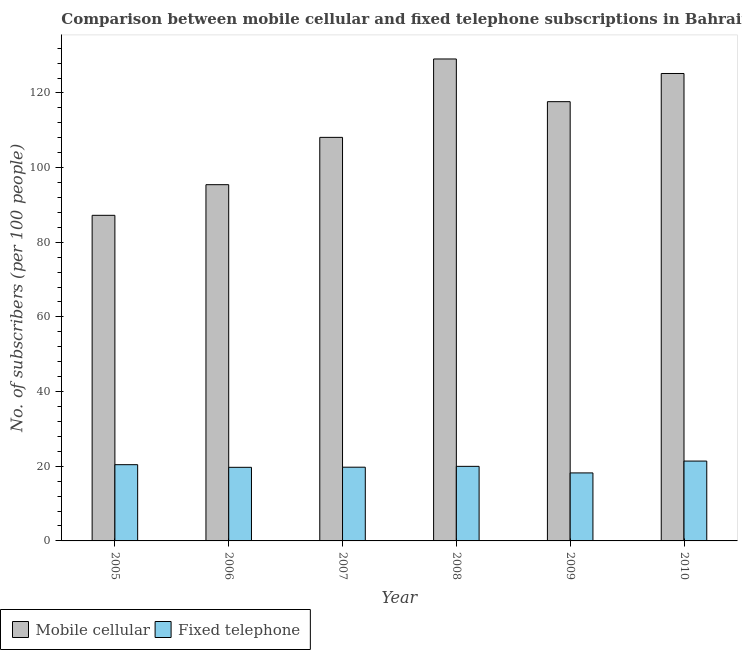Are the number of bars on each tick of the X-axis equal?
Provide a short and direct response. Yes. How many bars are there on the 6th tick from the left?
Offer a terse response. 2. In how many cases, is the number of bars for a given year not equal to the number of legend labels?
Make the answer very short. 0. What is the number of fixed telephone subscribers in 2007?
Provide a succinct answer. 19.75. Across all years, what is the maximum number of fixed telephone subscribers?
Your answer should be very brief. 21.39. Across all years, what is the minimum number of fixed telephone subscribers?
Make the answer very short. 18.22. In which year was the number of mobile cellular subscribers minimum?
Ensure brevity in your answer.  2005. What is the total number of fixed telephone subscribers in the graph?
Offer a very short reply. 119.47. What is the difference between the number of mobile cellular subscribers in 2005 and that in 2010?
Offer a very short reply. -37.99. What is the difference between the number of fixed telephone subscribers in 2007 and the number of mobile cellular subscribers in 2009?
Your response must be concise. 1.53. What is the average number of fixed telephone subscribers per year?
Make the answer very short. 19.91. In the year 2006, what is the difference between the number of fixed telephone subscribers and number of mobile cellular subscribers?
Your answer should be very brief. 0. What is the ratio of the number of mobile cellular subscribers in 2009 to that in 2010?
Give a very brief answer. 0.94. Is the number of mobile cellular subscribers in 2009 less than that in 2010?
Ensure brevity in your answer.  Yes. Is the difference between the number of fixed telephone subscribers in 2007 and 2010 greater than the difference between the number of mobile cellular subscribers in 2007 and 2010?
Provide a short and direct response. No. What is the difference between the highest and the second highest number of mobile cellular subscribers?
Your answer should be compact. 3.89. What is the difference between the highest and the lowest number of mobile cellular subscribers?
Ensure brevity in your answer.  41.88. In how many years, is the number of fixed telephone subscribers greater than the average number of fixed telephone subscribers taken over all years?
Your answer should be very brief. 3. What does the 2nd bar from the left in 2010 represents?
Your answer should be very brief. Fixed telephone. What does the 2nd bar from the right in 2009 represents?
Give a very brief answer. Mobile cellular. How many bars are there?
Offer a very short reply. 12. Are all the bars in the graph horizontal?
Your answer should be very brief. No. How many years are there in the graph?
Offer a very short reply. 6. What is the difference between two consecutive major ticks on the Y-axis?
Offer a terse response. 20. Are the values on the major ticks of Y-axis written in scientific E-notation?
Your answer should be compact. No. Does the graph contain grids?
Your answer should be compact. No. Where does the legend appear in the graph?
Your answer should be compact. Bottom left. How many legend labels are there?
Provide a short and direct response. 2. What is the title of the graph?
Offer a very short reply. Comparison between mobile cellular and fixed telephone subscriptions in Bahrain. Does "Resident" appear as one of the legend labels in the graph?
Your answer should be compact. No. What is the label or title of the X-axis?
Your answer should be very brief. Year. What is the label or title of the Y-axis?
Ensure brevity in your answer.  No. of subscribers (per 100 people). What is the No. of subscribers (per 100 people) of Mobile cellular in 2005?
Your response must be concise. 87.22. What is the No. of subscribers (per 100 people) in Fixed telephone in 2005?
Make the answer very short. 20.42. What is the No. of subscribers (per 100 people) of Mobile cellular in 2006?
Your response must be concise. 95.42. What is the No. of subscribers (per 100 people) of Fixed telephone in 2006?
Ensure brevity in your answer.  19.72. What is the No. of subscribers (per 100 people) of Mobile cellular in 2007?
Provide a succinct answer. 108.1. What is the No. of subscribers (per 100 people) of Fixed telephone in 2007?
Your answer should be very brief. 19.75. What is the No. of subscribers (per 100 people) of Mobile cellular in 2008?
Make the answer very short. 129.1. What is the No. of subscribers (per 100 people) in Fixed telephone in 2008?
Provide a short and direct response. 19.97. What is the No. of subscribers (per 100 people) of Mobile cellular in 2009?
Keep it short and to the point. 117.66. What is the No. of subscribers (per 100 people) of Fixed telephone in 2009?
Your answer should be compact. 18.22. What is the No. of subscribers (per 100 people) of Mobile cellular in 2010?
Keep it short and to the point. 125.21. What is the No. of subscribers (per 100 people) of Fixed telephone in 2010?
Keep it short and to the point. 21.39. Across all years, what is the maximum No. of subscribers (per 100 people) of Mobile cellular?
Give a very brief answer. 129.1. Across all years, what is the maximum No. of subscribers (per 100 people) in Fixed telephone?
Offer a very short reply. 21.39. Across all years, what is the minimum No. of subscribers (per 100 people) of Mobile cellular?
Give a very brief answer. 87.22. Across all years, what is the minimum No. of subscribers (per 100 people) in Fixed telephone?
Offer a terse response. 18.22. What is the total No. of subscribers (per 100 people) of Mobile cellular in the graph?
Your response must be concise. 662.71. What is the total No. of subscribers (per 100 people) of Fixed telephone in the graph?
Give a very brief answer. 119.47. What is the difference between the No. of subscribers (per 100 people) in Mobile cellular in 2005 and that in 2006?
Your answer should be compact. -8.21. What is the difference between the No. of subscribers (per 100 people) of Fixed telephone in 2005 and that in 2006?
Provide a succinct answer. 0.7. What is the difference between the No. of subscribers (per 100 people) in Mobile cellular in 2005 and that in 2007?
Provide a succinct answer. -20.88. What is the difference between the No. of subscribers (per 100 people) in Fixed telephone in 2005 and that in 2007?
Make the answer very short. 0.67. What is the difference between the No. of subscribers (per 100 people) in Mobile cellular in 2005 and that in 2008?
Your answer should be compact. -41.88. What is the difference between the No. of subscribers (per 100 people) in Fixed telephone in 2005 and that in 2008?
Your answer should be compact. 0.45. What is the difference between the No. of subscribers (per 100 people) of Mobile cellular in 2005 and that in 2009?
Offer a very short reply. -30.44. What is the difference between the No. of subscribers (per 100 people) of Fixed telephone in 2005 and that in 2009?
Your response must be concise. 2.2. What is the difference between the No. of subscribers (per 100 people) in Mobile cellular in 2005 and that in 2010?
Offer a very short reply. -37.99. What is the difference between the No. of subscribers (per 100 people) in Fixed telephone in 2005 and that in 2010?
Your answer should be compact. -0.97. What is the difference between the No. of subscribers (per 100 people) of Mobile cellular in 2006 and that in 2007?
Your answer should be compact. -12.68. What is the difference between the No. of subscribers (per 100 people) in Fixed telephone in 2006 and that in 2007?
Keep it short and to the point. -0.03. What is the difference between the No. of subscribers (per 100 people) of Mobile cellular in 2006 and that in 2008?
Ensure brevity in your answer.  -33.67. What is the difference between the No. of subscribers (per 100 people) in Fixed telephone in 2006 and that in 2008?
Your answer should be compact. -0.26. What is the difference between the No. of subscribers (per 100 people) in Mobile cellular in 2006 and that in 2009?
Make the answer very short. -22.24. What is the difference between the No. of subscribers (per 100 people) of Fixed telephone in 2006 and that in 2009?
Give a very brief answer. 1.5. What is the difference between the No. of subscribers (per 100 people) of Mobile cellular in 2006 and that in 2010?
Provide a succinct answer. -29.78. What is the difference between the No. of subscribers (per 100 people) of Fixed telephone in 2006 and that in 2010?
Your answer should be very brief. -1.67. What is the difference between the No. of subscribers (per 100 people) of Mobile cellular in 2007 and that in 2008?
Your response must be concise. -21. What is the difference between the No. of subscribers (per 100 people) in Fixed telephone in 2007 and that in 2008?
Your answer should be very brief. -0.23. What is the difference between the No. of subscribers (per 100 people) of Mobile cellular in 2007 and that in 2009?
Provide a short and direct response. -9.56. What is the difference between the No. of subscribers (per 100 people) in Fixed telephone in 2007 and that in 2009?
Offer a terse response. 1.53. What is the difference between the No. of subscribers (per 100 people) in Mobile cellular in 2007 and that in 2010?
Offer a terse response. -17.11. What is the difference between the No. of subscribers (per 100 people) of Fixed telephone in 2007 and that in 2010?
Ensure brevity in your answer.  -1.64. What is the difference between the No. of subscribers (per 100 people) in Mobile cellular in 2008 and that in 2009?
Make the answer very short. 11.44. What is the difference between the No. of subscribers (per 100 people) in Fixed telephone in 2008 and that in 2009?
Your answer should be very brief. 1.76. What is the difference between the No. of subscribers (per 100 people) of Mobile cellular in 2008 and that in 2010?
Ensure brevity in your answer.  3.89. What is the difference between the No. of subscribers (per 100 people) of Fixed telephone in 2008 and that in 2010?
Offer a terse response. -1.42. What is the difference between the No. of subscribers (per 100 people) of Mobile cellular in 2009 and that in 2010?
Ensure brevity in your answer.  -7.55. What is the difference between the No. of subscribers (per 100 people) of Fixed telephone in 2009 and that in 2010?
Keep it short and to the point. -3.17. What is the difference between the No. of subscribers (per 100 people) in Mobile cellular in 2005 and the No. of subscribers (per 100 people) in Fixed telephone in 2006?
Your answer should be very brief. 67.5. What is the difference between the No. of subscribers (per 100 people) in Mobile cellular in 2005 and the No. of subscribers (per 100 people) in Fixed telephone in 2007?
Offer a terse response. 67.47. What is the difference between the No. of subscribers (per 100 people) of Mobile cellular in 2005 and the No. of subscribers (per 100 people) of Fixed telephone in 2008?
Keep it short and to the point. 67.24. What is the difference between the No. of subscribers (per 100 people) of Mobile cellular in 2005 and the No. of subscribers (per 100 people) of Fixed telephone in 2009?
Your response must be concise. 69. What is the difference between the No. of subscribers (per 100 people) in Mobile cellular in 2005 and the No. of subscribers (per 100 people) in Fixed telephone in 2010?
Provide a succinct answer. 65.83. What is the difference between the No. of subscribers (per 100 people) of Mobile cellular in 2006 and the No. of subscribers (per 100 people) of Fixed telephone in 2007?
Give a very brief answer. 75.68. What is the difference between the No. of subscribers (per 100 people) of Mobile cellular in 2006 and the No. of subscribers (per 100 people) of Fixed telephone in 2008?
Your response must be concise. 75.45. What is the difference between the No. of subscribers (per 100 people) of Mobile cellular in 2006 and the No. of subscribers (per 100 people) of Fixed telephone in 2009?
Ensure brevity in your answer.  77.21. What is the difference between the No. of subscribers (per 100 people) in Mobile cellular in 2006 and the No. of subscribers (per 100 people) in Fixed telephone in 2010?
Offer a very short reply. 74.03. What is the difference between the No. of subscribers (per 100 people) in Mobile cellular in 2007 and the No. of subscribers (per 100 people) in Fixed telephone in 2008?
Provide a short and direct response. 88.13. What is the difference between the No. of subscribers (per 100 people) in Mobile cellular in 2007 and the No. of subscribers (per 100 people) in Fixed telephone in 2009?
Keep it short and to the point. 89.88. What is the difference between the No. of subscribers (per 100 people) in Mobile cellular in 2007 and the No. of subscribers (per 100 people) in Fixed telephone in 2010?
Provide a succinct answer. 86.71. What is the difference between the No. of subscribers (per 100 people) of Mobile cellular in 2008 and the No. of subscribers (per 100 people) of Fixed telephone in 2009?
Keep it short and to the point. 110.88. What is the difference between the No. of subscribers (per 100 people) in Mobile cellular in 2008 and the No. of subscribers (per 100 people) in Fixed telephone in 2010?
Provide a succinct answer. 107.71. What is the difference between the No. of subscribers (per 100 people) of Mobile cellular in 2009 and the No. of subscribers (per 100 people) of Fixed telephone in 2010?
Ensure brevity in your answer.  96.27. What is the average No. of subscribers (per 100 people) of Mobile cellular per year?
Offer a very short reply. 110.45. What is the average No. of subscribers (per 100 people) in Fixed telephone per year?
Offer a terse response. 19.91. In the year 2005, what is the difference between the No. of subscribers (per 100 people) of Mobile cellular and No. of subscribers (per 100 people) of Fixed telephone?
Provide a succinct answer. 66.8. In the year 2006, what is the difference between the No. of subscribers (per 100 people) in Mobile cellular and No. of subscribers (per 100 people) in Fixed telephone?
Keep it short and to the point. 75.71. In the year 2007, what is the difference between the No. of subscribers (per 100 people) in Mobile cellular and No. of subscribers (per 100 people) in Fixed telephone?
Keep it short and to the point. 88.35. In the year 2008, what is the difference between the No. of subscribers (per 100 people) in Mobile cellular and No. of subscribers (per 100 people) in Fixed telephone?
Ensure brevity in your answer.  109.12. In the year 2009, what is the difference between the No. of subscribers (per 100 people) of Mobile cellular and No. of subscribers (per 100 people) of Fixed telephone?
Your answer should be very brief. 99.44. In the year 2010, what is the difference between the No. of subscribers (per 100 people) in Mobile cellular and No. of subscribers (per 100 people) in Fixed telephone?
Ensure brevity in your answer.  103.82. What is the ratio of the No. of subscribers (per 100 people) of Mobile cellular in 2005 to that in 2006?
Provide a succinct answer. 0.91. What is the ratio of the No. of subscribers (per 100 people) in Fixed telephone in 2005 to that in 2006?
Make the answer very short. 1.04. What is the ratio of the No. of subscribers (per 100 people) of Mobile cellular in 2005 to that in 2007?
Make the answer very short. 0.81. What is the ratio of the No. of subscribers (per 100 people) in Fixed telephone in 2005 to that in 2007?
Give a very brief answer. 1.03. What is the ratio of the No. of subscribers (per 100 people) of Mobile cellular in 2005 to that in 2008?
Offer a very short reply. 0.68. What is the ratio of the No. of subscribers (per 100 people) in Fixed telephone in 2005 to that in 2008?
Give a very brief answer. 1.02. What is the ratio of the No. of subscribers (per 100 people) in Mobile cellular in 2005 to that in 2009?
Give a very brief answer. 0.74. What is the ratio of the No. of subscribers (per 100 people) of Fixed telephone in 2005 to that in 2009?
Offer a terse response. 1.12. What is the ratio of the No. of subscribers (per 100 people) in Mobile cellular in 2005 to that in 2010?
Your answer should be compact. 0.7. What is the ratio of the No. of subscribers (per 100 people) of Fixed telephone in 2005 to that in 2010?
Make the answer very short. 0.95. What is the ratio of the No. of subscribers (per 100 people) of Mobile cellular in 2006 to that in 2007?
Provide a short and direct response. 0.88. What is the ratio of the No. of subscribers (per 100 people) in Mobile cellular in 2006 to that in 2008?
Make the answer very short. 0.74. What is the ratio of the No. of subscribers (per 100 people) in Fixed telephone in 2006 to that in 2008?
Provide a succinct answer. 0.99. What is the ratio of the No. of subscribers (per 100 people) in Mobile cellular in 2006 to that in 2009?
Your answer should be very brief. 0.81. What is the ratio of the No. of subscribers (per 100 people) in Fixed telephone in 2006 to that in 2009?
Ensure brevity in your answer.  1.08. What is the ratio of the No. of subscribers (per 100 people) of Mobile cellular in 2006 to that in 2010?
Give a very brief answer. 0.76. What is the ratio of the No. of subscribers (per 100 people) in Fixed telephone in 2006 to that in 2010?
Ensure brevity in your answer.  0.92. What is the ratio of the No. of subscribers (per 100 people) of Mobile cellular in 2007 to that in 2008?
Offer a very short reply. 0.84. What is the ratio of the No. of subscribers (per 100 people) of Mobile cellular in 2007 to that in 2009?
Provide a succinct answer. 0.92. What is the ratio of the No. of subscribers (per 100 people) in Fixed telephone in 2007 to that in 2009?
Make the answer very short. 1.08. What is the ratio of the No. of subscribers (per 100 people) in Mobile cellular in 2007 to that in 2010?
Provide a succinct answer. 0.86. What is the ratio of the No. of subscribers (per 100 people) in Fixed telephone in 2007 to that in 2010?
Keep it short and to the point. 0.92. What is the ratio of the No. of subscribers (per 100 people) of Mobile cellular in 2008 to that in 2009?
Offer a very short reply. 1.1. What is the ratio of the No. of subscribers (per 100 people) in Fixed telephone in 2008 to that in 2009?
Make the answer very short. 1.1. What is the ratio of the No. of subscribers (per 100 people) in Mobile cellular in 2008 to that in 2010?
Keep it short and to the point. 1.03. What is the ratio of the No. of subscribers (per 100 people) of Fixed telephone in 2008 to that in 2010?
Ensure brevity in your answer.  0.93. What is the ratio of the No. of subscribers (per 100 people) in Mobile cellular in 2009 to that in 2010?
Make the answer very short. 0.94. What is the ratio of the No. of subscribers (per 100 people) of Fixed telephone in 2009 to that in 2010?
Ensure brevity in your answer.  0.85. What is the difference between the highest and the second highest No. of subscribers (per 100 people) of Mobile cellular?
Ensure brevity in your answer.  3.89. What is the difference between the highest and the second highest No. of subscribers (per 100 people) in Fixed telephone?
Offer a very short reply. 0.97. What is the difference between the highest and the lowest No. of subscribers (per 100 people) in Mobile cellular?
Your answer should be very brief. 41.88. What is the difference between the highest and the lowest No. of subscribers (per 100 people) in Fixed telephone?
Your answer should be compact. 3.17. 